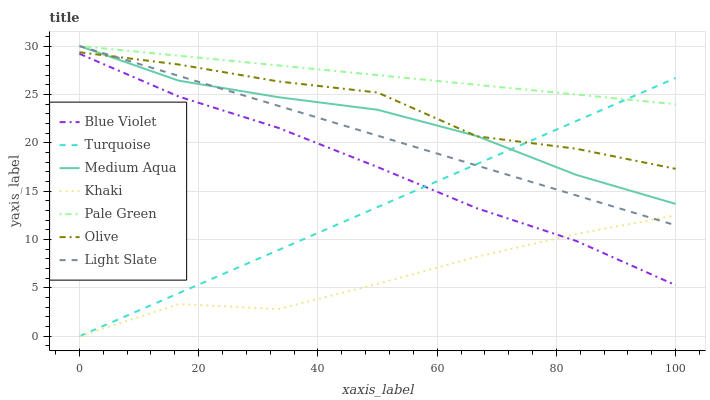Does Khaki have the minimum area under the curve?
Answer yes or no. Yes. Does Pale Green have the maximum area under the curve?
Answer yes or no. Yes. Does Light Slate have the minimum area under the curve?
Answer yes or no. No. Does Light Slate have the maximum area under the curve?
Answer yes or no. No. Is Light Slate the smoothest?
Answer yes or no. Yes. Is Olive the roughest?
Answer yes or no. Yes. Is Khaki the smoothest?
Answer yes or no. No. Is Khaki the roughest?
Answer yes or no. No. Does Turquoise have the lowest value?
Answer yes or no. Yes. Does Light Slate have the lowest value?
Answer yes or no. No. Does Medium Aqua have the highest value?
Answer yes or no. Yes. Does Khaki have the highest value?
Answer yes or no. No. Is Olive less than Pale Green?
Answer yes or no. Yes. Is Olive greater than Blue Violet?
Answer yes or no. Yes. Does Light Slate intersect Pale Green?
Answer yes or no. Yes. Is Light Slate less than Pale Green?
Answer yes or no. No. Is Light Slate greater than Pale Green?
Answer yes or no. No. Does Olive intersect Pale Green?
Answer yes or no. No. 